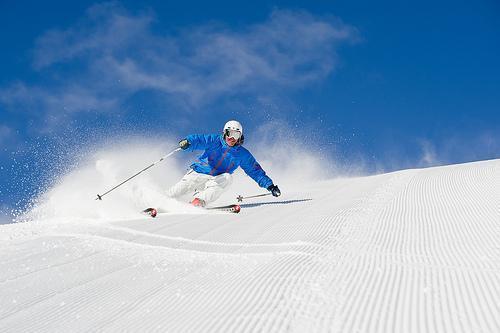How many people are in the photo?
Give a very brief answer. 1. 